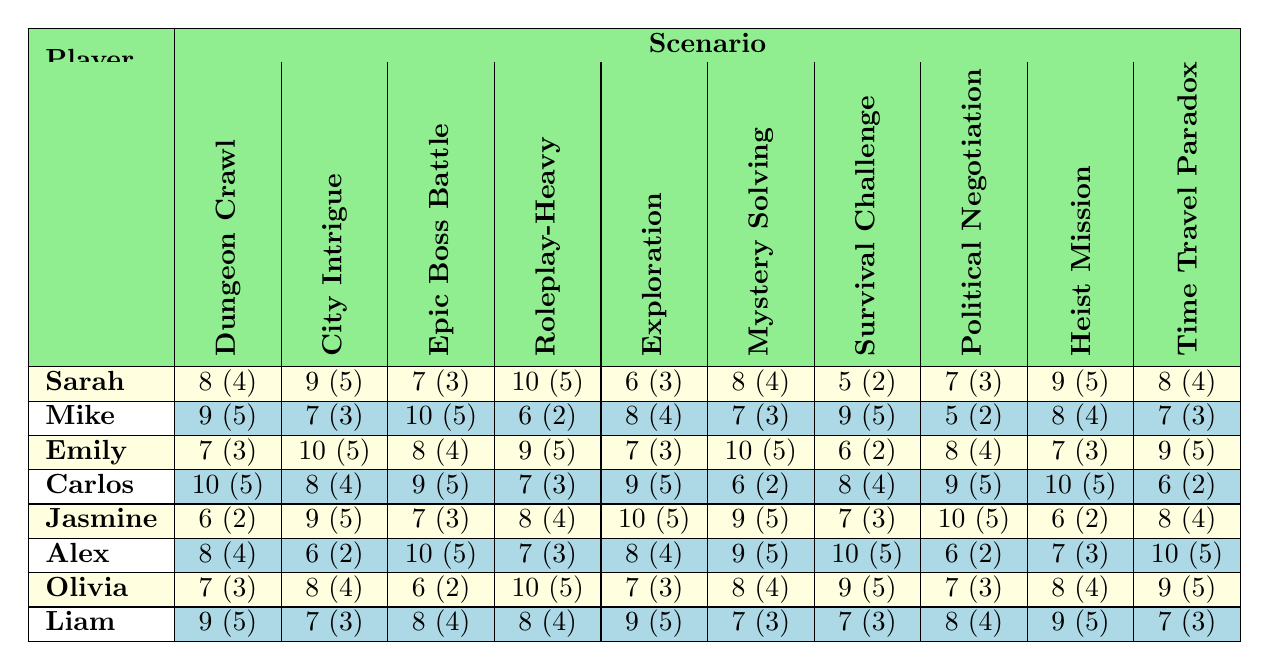What was Sarah's satisfaction rating for the Roleplay-Heavy session? According to the table, Sarah's rating for the Roleplay-Heavy session is 10.
Answer: 10 Which player rated the Epic Boss Battle with the highest satisfaction? Carlos rated the Epic Boss Battle with a score of 9, which is the highest among all players.
Answer: Carlos What is the average satisfaction rating for the City Intrigue scenario? The ratings for the City Intrigue scenario are 9, 7, 10, 8, 9, 6, 8, and 7. We sum these ratings (9 + 7 + 10 + 8 + 9 + 6 + 8 + 7) = 66 and divide by 8 (the number of players) to get an average of 8.25.
Answer: 8.25 Did any player rate the Dungeon Crawl scenario lower than 7? Yes, Sarah gave the Dungeon Crawl scenario a rating of 8, and Jasmine rated it 6, which is lower than 7.
Answer: Yes Which scenario received the lowest average engagement level? The engagement levels for each scenario can be collected as follows: Dungeon Crawl (4+5+3+5+2+4+3+5 = 31), City Intrigue (5+3+5+4+5+2+4+3 = 31), Epic Boss Battle (3+5+4+5+3+5+2+4 = 31), Roleplay-Heavy Session (5+2+5+3+4+5+5+4 = 33), Exploration Adventure (3+4+3+5+5+4+3+5 = 36), Mystery Solving (4+3+5+2+5+5+4+7 = 35), Survival Challenge (2+5+2+4+3+5+5+3 = 31), Political Negotiation (5+2+4+5+2+3+3+4 = 30), Heist Mission (5+4+3+3+2+3+4+5 = 31), Time Travel Paradox (4+3+5+5+4+5+5+3 = 39). Political Negotiation has the lowest total engagement score of 30 out of 8 players, giving it an average engagement level of 3.75.
Answer: Political Negotiation Which two players gave the same rating for the Heist Mission scenario? After reviewing the ratings for the Heist Mission, we see that both Carlos and Olivia gave it a score of 9.
Answer: Carlos and Olivia What was the total satisfaction rating for Emily across all scenarios? Emily's satisfaction ratings are 7, 10, 8, 9, 7, 10, 6, 8, 7, and 9. Adding these gives a total of (7 + 10 + 8 + 9 + 7 + 10 + 6 + 8 + 7 + 9) = 81.
Answer: 81 How many players rated the Survival Challenge scenario above 6? The ratings for the Survival Challenge are 5, 9, 6, 8, 7, 10, 9, and 7. Only Carlos (9), Jasmine (10), and Olivia (9) rated it above 6, which accounts for 5 players overall.
Answer: 5 Which scenario had the highest emotional impact rating among the players? The Emotional Impact ratings are subjective and not assigned numerical values, but we can analyze the words used. For instance, scenarios with words like “Exhilarated," "Intrigued," and "Empathetic” received prominent mentions, seen in various scenarios. The most frequent positive descriptor across scenarios was "Engaged," resulting most likely from the Exploration Adventure.
Answer: Exploration Adventure Did Liam rate the City Intrigue scenario higher than Emily? Liam rated the City Intrigue scenario at 7, while Emily rated it 10. Since 7 is not higher than 10, the answer is no.
Answer: No 